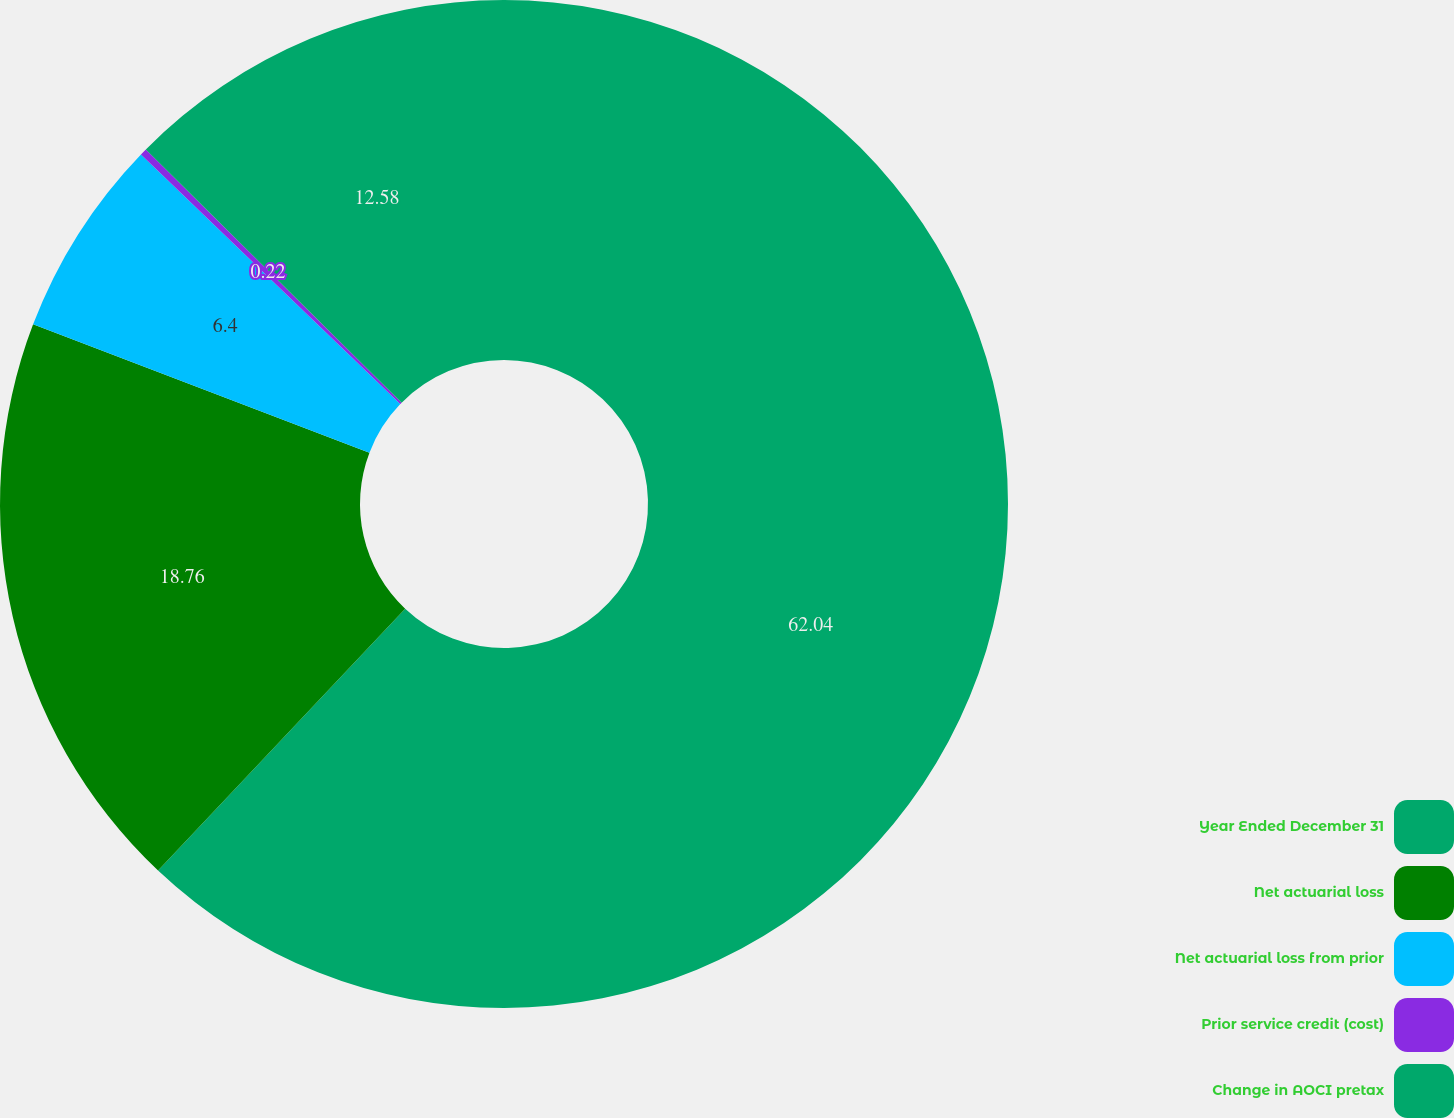<chart> <loc_0><loc_0><loc_500><loc_500><pie_chart><fcel>Year Ended December 31<fcel>Net actuarial loss<fcel>Net actuarial loss from prior<fcel>Prior service credit (cost)<fcel>Change in AOCI pretax<nl><fcel>62.04%<fcel>18.76%<fcel>6.4%<fcel>0.22%<fcel>12.58%<nl></chart> 